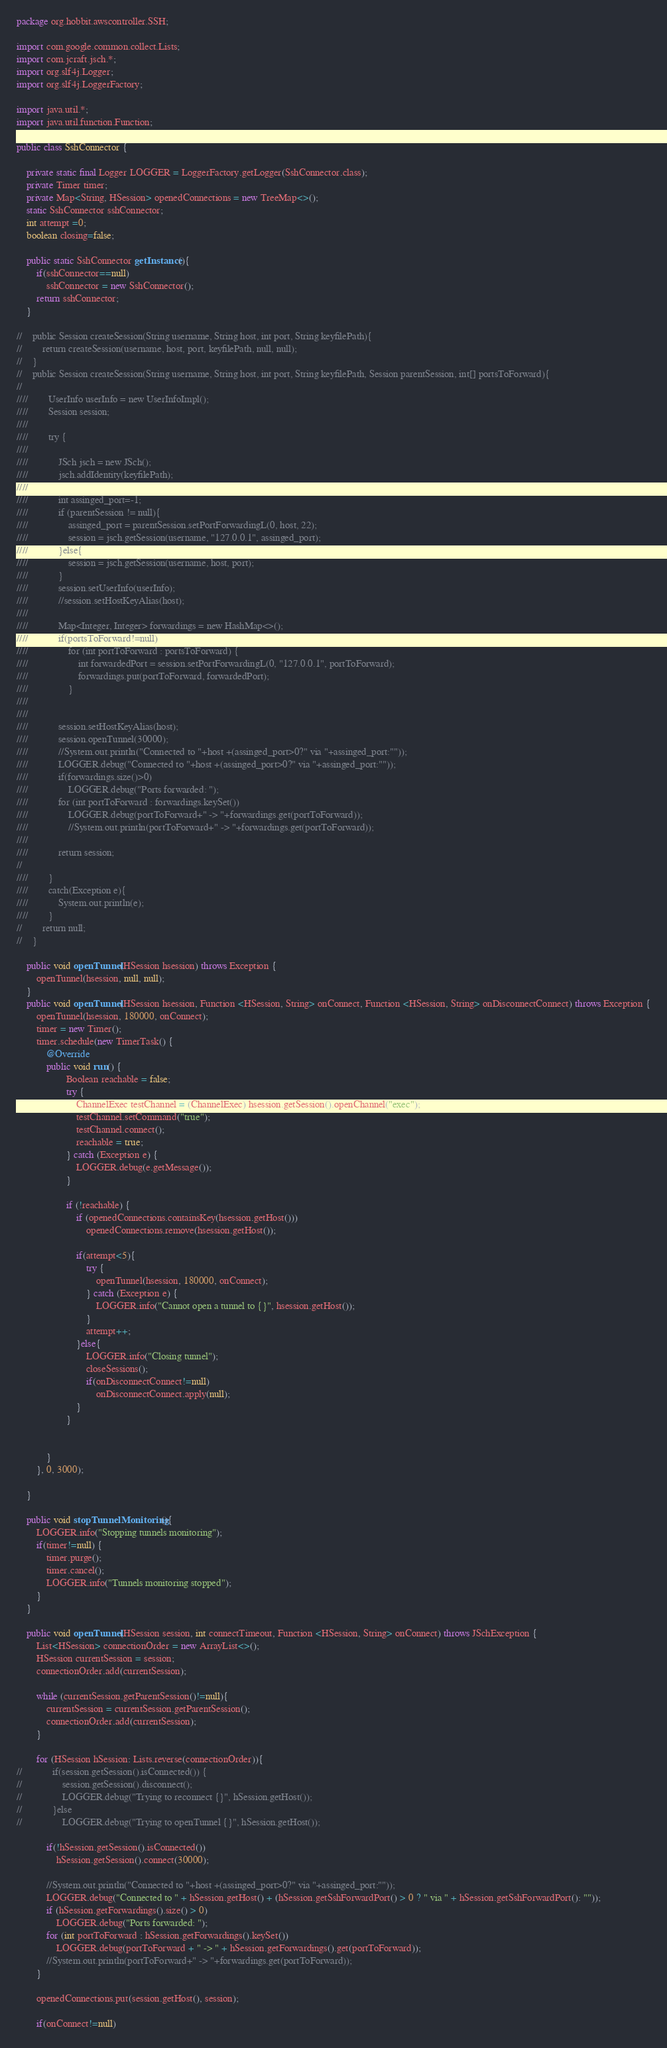Convert code to text. <code><loc_0><loc_0><loc_500><loc_500><_Java_>package org.hobbit.awscontroller.SSH;

import com.google.common.collect.Lists;
import com.jcraft.jsch.*;
import org.slf4j.Logger;
import org.slf4j.LoggerFactory;

import java.util.*;
import java.util.function.Function;

public class SshConnector {

    private static final Logger LOGGER = LoggerFactory.getLogger(SshConnector.class);
    private Timer timer;
    private Map<String, HSession> openedConnections = new TreeMap<>();
    static SshConnector sshConnector;
    int attempt =0;
    boolean closing=false;

    public static SshConnector getInstance(){
        if(sshConnector==null)
            sshConnector = new SshConnector();
        return sshConnector;
    }

//    public Session createSession(String username, String host, int port, String keyfilePath){
//        return createSession(username, host, port, keyfilePath, null, null);
//    }
//    public Session createSession(String username, String host, int port, String keyfilePath, Session parentSession, int[] portsToForward){
//
////        UserInfo userInfo = new UserInfoImpl();
////        Session session;
////
////        try {
////
////            JSch jsch = new JSch();
////            jsch.addIdentity(keyfilePath);
////
////            int assinged_port=-1;
////            if (parentSession != null){
////                assinged_port = parentSession.setPortForwardingL(0, host, 22);
////                session = jsch.getSession(username, "127.0.0.1", assinged_port);
////            }else{
////                session = jsch.getSession(username, host, port);
////            }
////            session.setUserInfo(userInfo);
////            //session.setHostKeyAlias(host);
////
////            Map<Integer, Integer> forwardings = new HashMap<>();
////            if(portsToForward!=null)
////                for (int portToForward : portsToForward) {
////                    int forwardedPort = session.setPortForwardingL(0, "127.0.0.1", portToForward);
////                    forwardings.put(portToForward, forwardedPort);
////                }
////
////
////            session.setHostKeyAlias(host);
////            session.openTunnel(30000);
////            //System.out.println("Connected to "+host +(assinged_port>0?" via "+assinged_port:""));
////            LOGGER.debug("Connected to "+host +(assinged_port>0?" via "+assinged_port:""));
////            if(forwardings.size()>0)
////                LOGGER.debug("Ports forwarded: ");
////            for (int portToForward : forwardings.keySet())
////                LOGGER.debug(portToForward+" -> "+forwardings.get(portToForward));
////                //System.out.println(portToForward+" -> "+forwardings.get(portToForward));
////
////            return session;
//
////        }
////        catch(Exception e){
////            System.out.println(e);
////        }
//        return null;
//    }

    public void openTunnel(HSession hsession) throws Exception {
        openTunnel(hsession, null, null);
    }
    public void openTunnel(HSession hsession, Function <HSession, String> onConnect, Function <HSession, String> onDisconnectConnect) throws Exception {
        openTunnel(hsession, 180000, onConnect);
        timer = new Timer();
        timer.schedule(new TimerTask() {
            @Override
            public void run() {
                    Boolean reachable = false;
                    try {
                        ChannelExec testChannel = (ChannelExec) hsession.getSession().openChannel("exec");
                        testChannel.setCommand("true");
                        testChannel.connect();
                        reachable = true;
                    } catch (Exception e) {
                        LOGGER.debug(e.getMessage());
                    }

                    if (!reachable) {
                        if (openedConnections.containsKey(hsession.getHost()))
                            openedConnections.remove(hsession.getHost());

                        if(attempt<5){
                            try {
                                openTunnel(hsession, 180000, onConnect);
                            } catch (Exception e) {
                                LOGGER.info("Cannot open a tunnel to {}", hsession.getHost());
                            }
                            attempt++;
                        }else{
                            LOGGER.info("Closing tunnel");
                            closeSessions();
                            if(onDisconnectConnect!=null)
                                onDisconnectConnect.apply(null);
                        }
                    }


            }
        }, 0, 3000);

    }

    public void stopTunnelMonitoring(){
        LOGGER.info("Stopping tunnels monitoring");
        if(timer!=null) {
            timer.purge();
            timer.cancel();
            LOGGER.info("Tunnels monitoring stopped");
        }
    }

    public void openTunnel(HSession session, int connectTimeout, Function <HSession, String> onConnect) throws JSchException {
        List<HSession> connectionOrder = new ArrayList<>();
        HSession currentSession = session;
        connectionOrder.add(currentSession);

        while (currentSession.getParentSession()!=null){
            currentSession = currentSession.getParentSession();
            connectionOrder.add(currentSession);
        }

        for (HSession hSession: Lists.reverse(connectionOrder)){
//            if(session.getSession().isConnected()) {
//                session.getSession().disconnect();
//                LOGGER.debug("Trying to reconnect {}", hSession.getHost());
//            }else
//                LOGGER.debug("Trying to openTunnel {}", hSession.getHost());

            if(!hSession.getSession().isConnected())
                hSession.getSession().connect(30000);

            //System.out.println("Connected to "+host +(assinged_port>0?" via "+assinged_port:""));
            LOGGER.debug("Connected to " + hSession.getHost() + (hSession.getSshForwardPort() > 0 ? " via " + hSession.getSshForwardPort(): ""));
            if (hSession.getForwardings().size() > 0)
                LOGGER.debug("Ports forwarded: ");
            for (int portToForward : hSession.getForwardings().keySet())
                LOGGER.debug(portToForward + " -> " + hSession.getForwardings().get(portToForward));
            //System.out.println(portToForward+" -> "+forwardings.get(portToForward));
        }

        openedConnections.put(session.getHost(), session);

        if(onConnect!=null)</code> 